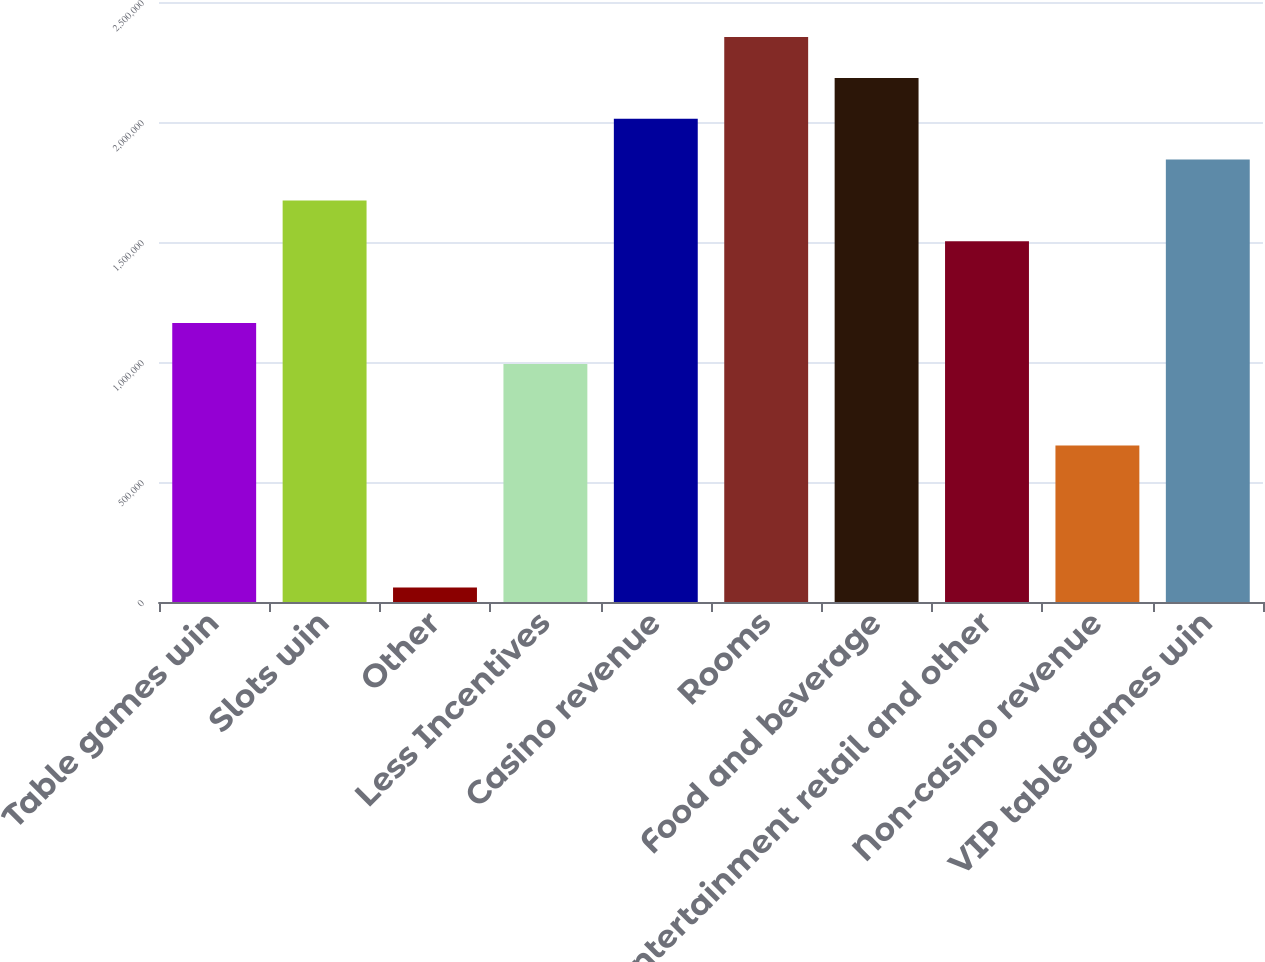Convert chart to OTSL. <chart><loc_0><loc_0><loc_500><loc_500><bar_chart><fcel>Table games win<fcel>Slots win<fcel>Other<fcel>Less Incentives<fcel>Casino revenue<fcel>Rooms<fcel>Food and beverage<fcel>Entertainment retail and other<fcel>Non-casino revenue<fcel>VIP table games win<nl><fcel>1.16235e+06<fcel>1.67302e+06<fcel>60620<fcel>992129<fcel>2.01347e+06<fcel>2.35391e+06<fcel>2.18369e+06<fcel>1.5028e+06<fcel>651683<fcel>1.84324e+06<nl></chart> 